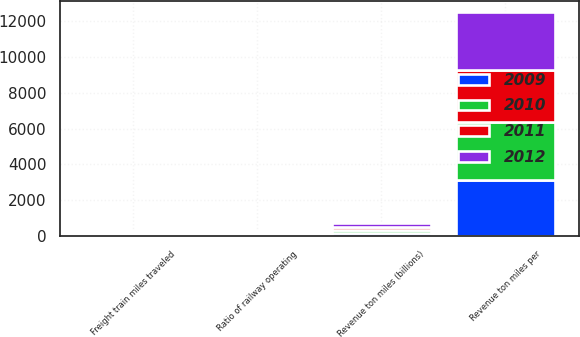Convert chart to OTSL. <chart><loc_0><loc_0><loc_500><loc_500><stacked_bar_chart><ecel><fcel>Revenue ton miles (billions)<fcel>Freight train miles traveled<fcel>Revenue ton miles per<fcel>Ratio of railway operating<nl><fcel>2009<fcel>186<fcel>76.3<fcel>3153<fcel>71.7<nl><fcel>2012<fcel>192<fcel>75.7<fcel>3207<fcel>71.2<nl><fcel>2010<fcel>182<fcel>72.6<fcel>3218<fcel>71.9<nl><fcel>2011<fcel>159<fcel>67.5<fcel>2900<fcel>75.4<nl></chart> 